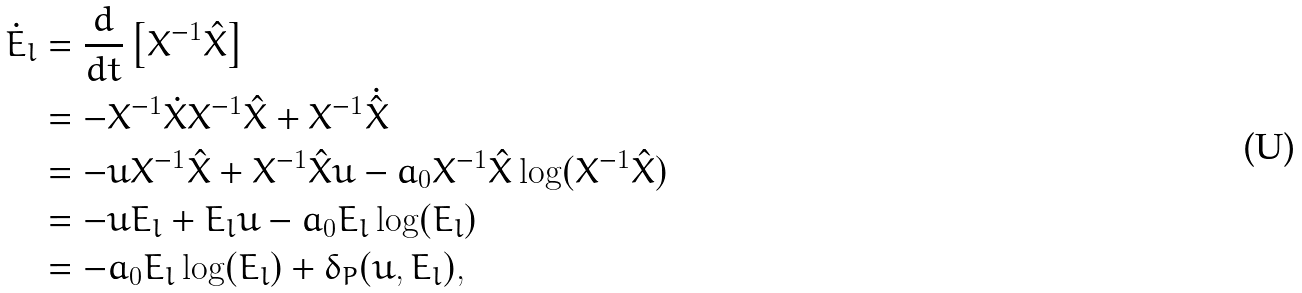Convert formula to latex. <formula><loc_0><loc_0><loc_500><loc_500>\dot { E } _ { l } & = \frac { d } { d t } \left [ X ^ { - 1 } \hat { X } \right ] \\ & = - X ^ { - 1 } \dot { X } X ^ { - 1 } \hat { X } + X ^ { - 1 } \dot { \hat { X } } \\ & = - u X ^ { - 1 } \hat { X } + X ^ { - 1 } \hat { X } u - a _ { 0 } X ^ { - 1 } \hat { X } \log ( X ^ { - 1 } \hat { X } ) \\ & = - u E _ { l } + E _ { l } u - a _ { 0 } E _ { l } \log ( E _ { l } ) \\ & = - a _ { 0 } E _ { l } \log ( E _ { l } ) + \delta _ { P } ( u , E _ { l } ) ,</formula> 